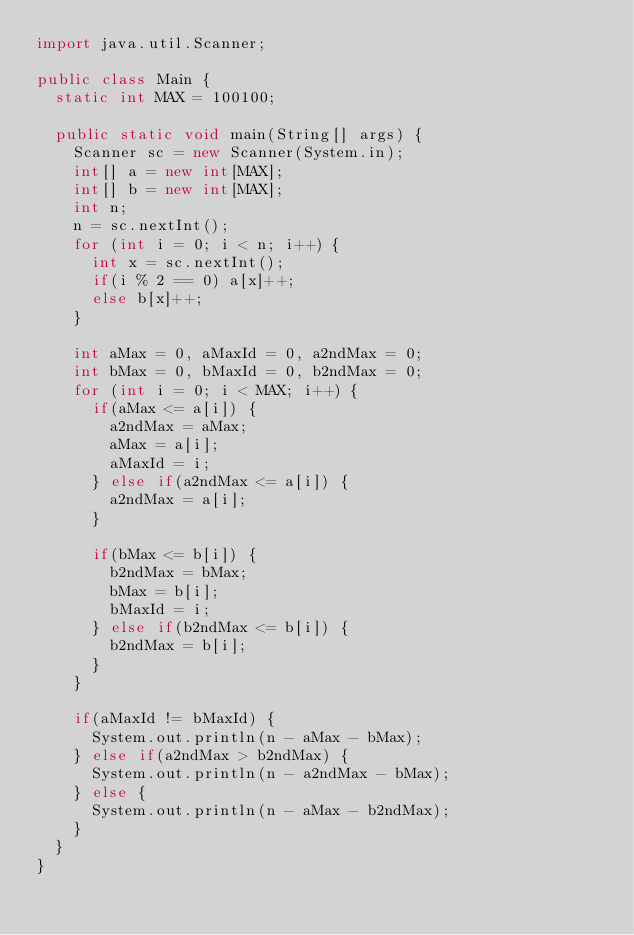Convert code to text. <code><loc_0><loc_0><loc_500><loc_500><_Java_>import java.util.Scanner;

public class Main {
	static int MAX = 100100;

	public static void main(String[] args) {
		Scanner sc = new Scanner(System.in);
		int[] a = new int[MAX];
		int[] b = new int[MAX];
		int n;
		n = sc.nextInt();
		for (int i = 0; i < n; i++) {
			int x = sc.nextInt();
			if(i % 2 == 0) a[x]++;
			else b[x]++;
		}

		int aMax = 0, aMaxId = 0, a2ndMax = 0;
		int bMax = 0, bMaxId = 0, b2ndMax = 0;
		for (int i = 0; i < MAX; i++) {
			if(aMax <= a[i]) {
				a2ndMax = aMax;
				aMax = a[i];
				aMaxId = i;
			} else if(a2ndMax <= a[i]) {
				a2ndMax = a[i];
			}

			if(bMax <= b[i]) {
				b2ndMax = bMax;
				bMax = b[i];
				bMaxId = i;
			} else if(b2ndMax <= b[i]) {
				b2ndMax = b[i];
			}
		}

		if(aMaxId != bMaxId) {
			System.out.println(n - aMax - bMax);
		} else if(a2ndMax > b2ndMax) {
			System.out.println(n - a2ndMax - bMax);
		} else {
			System.out.println(n - aMax - b2ndMax);
		}
	}
}</code> 